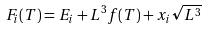<formula> <loc_0><loc_0><loc_500><loc_500>F _ { i } ( T ) = E _ { i } + L ^ { 3 } f ( T ) + x _ { i } \sqrt { L ^ { 3 } }</formula> 